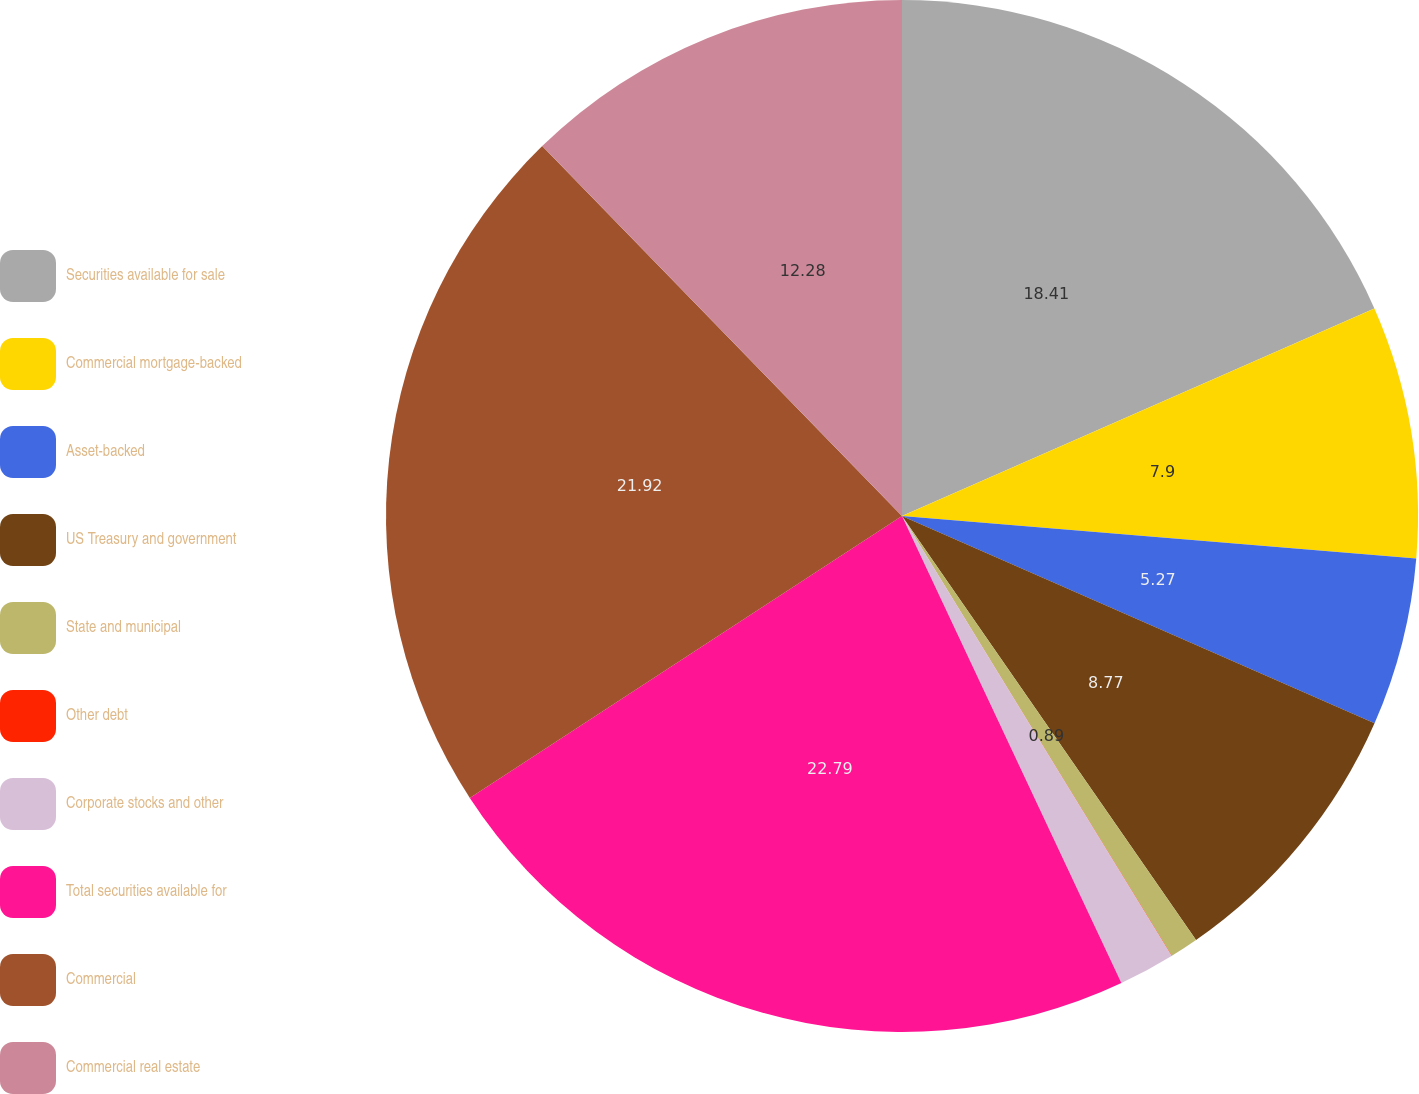Convert chart to OTSL. <chart><loc_0><loc_0><loc_500><loc_500><pie_chart><fcel>Securities available for sale<fcel>Commercial mortgage-backed<fcel>Asset-backed<fcel>US Treasury and government<fcel>State and municipal<fcel>Other debt<fcel>Corporate stocks and other<fcel>Total securities available for<fcel>Commercial<fcel>Commercial real estate<nl><fcel>18.41%<fcel>7.9%<fcel>5.27%<fcel>8.77%<fcel>0.89%<fcel>0.01%<fcel>1.76%<fcel>22.79%<fcel>21.92%<fcel>12.28%<nl></chart> 